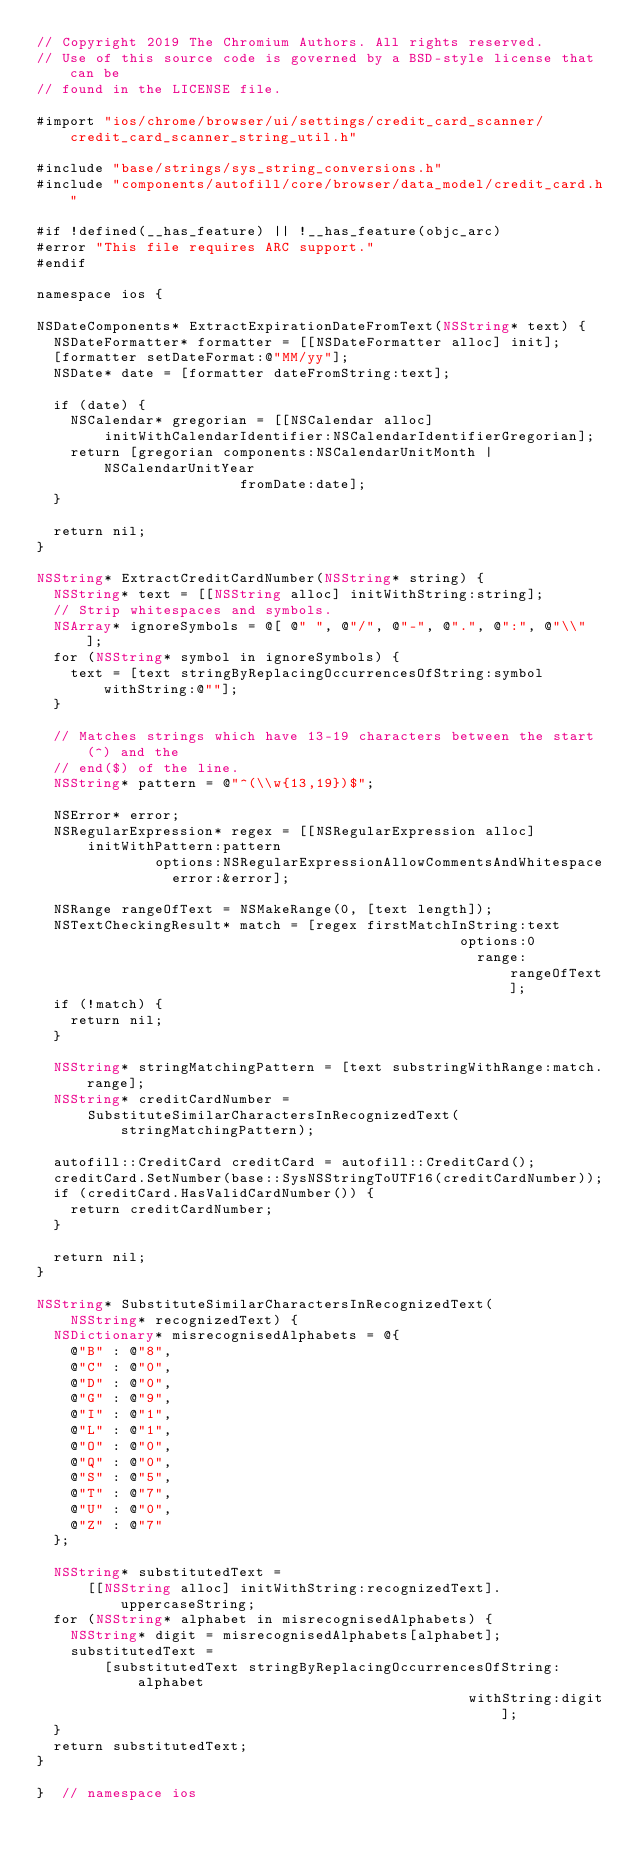<code> <loc_0><loc_0><loc_500><loc_500><_ObjectiveC_>// Copyright 2019 The Chromium Authors. All rights reserved.
// Use of this source code is governed by a BSD-style license that can be
// found in the LICENSE file.

#import "ios/chrome/browser/ui/settings/credit_card_scanner/credit_card_scanner_string_util.h"

#include "base/strings/sys_string_conversions.h"
#include "components/autofill/core/browser/data_model/credit_card.h"

#if !defined(__has_feature) || !__has_feature(objc_arc)
#error "This file requires ARC support."
#endif

namespace ios {

NSDateComponents* ExtractExpirationDateFromText(NSString* text) {
  NSDateFormatter* formatter = [[NSDateFormatter alloc] init];
  [formatter setDateFormat:@"MM/yy"];
  NSDate* date = [formatter dateFromString:text];

  if (date) {
    NSCalendar* gregorian = [[NSCalendar alloc]
        initWithCalendarIdentifier:NSCalendarIdentifierGregorian];
    return [gregorian components:NSCalendarUnitMonth | NSCalendarUnitYear
                        fromDate:date];
  }

  return nil;
}

NSString* ExtractCreditCardNumber(NSString* string) {
  NSString* text = [[NSString alloc] initWithString:string];
  // Strip whitespaces and symbols.
  NSArray* ignoreSymbols = @[ @" ", @"/", @"-", @".", @":", @"\\" ];
  for (NSString* symbol in ignoreSymbols) {
    text = [text stringByReplacingOccurrencesOfString:symbol withString:@""];
  }

  // Matches strings which have 13-19 characters between the start(^) and the
  // end($) of the line.
  NSString* pattern = @"^(\\w{13,19})$";

  NSError* error;
  NSRegularExpression* regex = [[NSRegularExpression alloc]
      initWithPattern:pattern
              options:NSRegularExpressionAllowCommentsAndWhitespace
                error:&error];

  NSRange rangeOfText = NSMakeRange(0, [text length]);
  NSTextCheckingResult* match = [regex firstMatchInString:text
                                                  options:0
                                                    range:rangeOfText];
  if (!match) {
    return nil;
  }

  NSString* stringMatchingPattern = [text substringWithRange:match.range];
  NSString* creditCardNumber =
      SubstituteSimilarCharactersInRecognizedText(stringMatchingPattern);

  autofill::CreditCard creditCard = autofill::CreditCard();
  creditCard.SetNumber(base::SysNSStringToUTF16(creditCardNumber));
  if (creditCard.HasValidCardNumber()) {
    return creditCardNumber;
  }

  return nil;
}

NSString* SubstituteSimilarCharactersInRecognizedText(
    NSString* recognizedText) {
  NSDictionary* misrecognisedAlphabets = @{
    @"B" : @"8",
    @"C" : @"0",
    @"D" : @"0",
    @"G" : @"9",
    @"I" : @"1",
    @"L" : @"1",
    @"O" : @"0",
    @"Q" : @"0",
    @"S" : @"5",
    @"T" : @"7",
    @"U" : @"0",
    @"Z" : @"7"
  };

  NSString* substitutedText =
      [[NSString alloc] initWithString:recognizedText].uppercaseString;
  for (NSString* alphabet in misrecognisedAlphabets) {
    NSString* digit = misrecognisedAlphabets[alphabet];
    substitutedText =
        [substitutedText stringByReplacingOccurrencesOfString:alphabet
                                                   withString:digit];
  }
  return substitutedText;
}

}  // namespace ios
</code> 